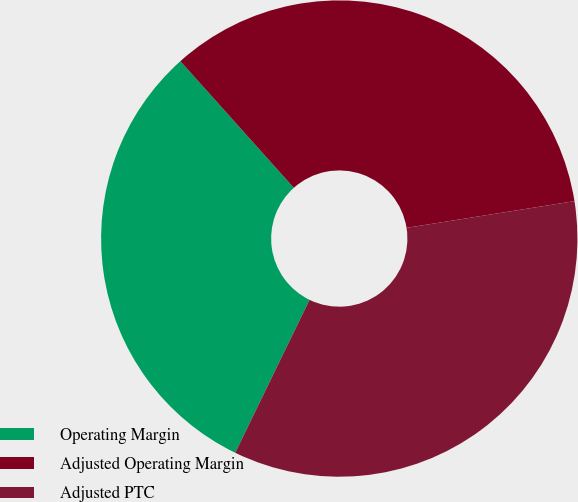<chart> <loc_0><loc_0><loc_500><loc_500><pie_chart><fcel>Operating Margin<fcel>Adjusted Operating Margin<fcel>Adjusted PTC<nl><fcel>31.18%<fcel>34.12%<fcel>34.71%<nl></chart> 